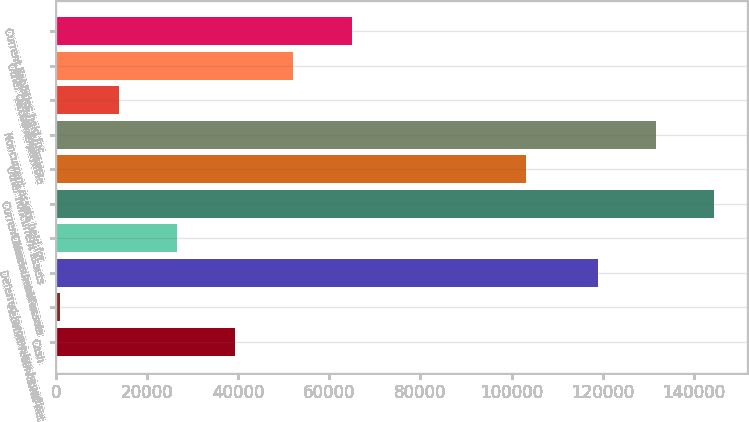<chart> <loc_0><loc_0><loc_500><loc_500><bar_chart><fcel>Cash<fcel>Account receivables net<fcel>Deferred income tax benefits<fcel>Other current assets<fcel>Current assets held for sale<fcel>Other noncurrent assets<fcel>Noncurrent assets held for<fcel>Accounts payable<fcel>Other current liabilities<fcel>Current liabilities held for<nl><fcel>39285.4<fcel>913<fcel>118919<fcel>26494.6<fcel>144501<fcel>103239<fcel>131710<fcel>13703.8<fcel>52076.2<fcel>64867<nl></chart> 